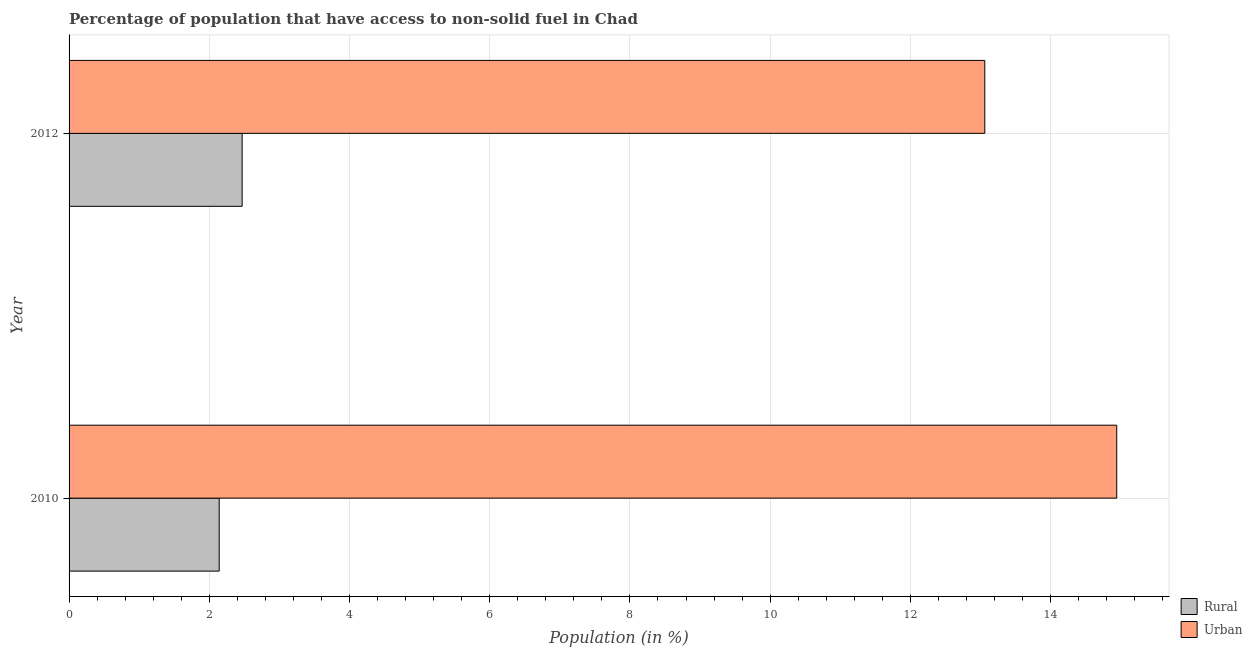How many different coloured bars are there?
Make the answer very short. 2. How many groups of bars are there?
Your answer should be very brief. 2. What is the label of the 1st group of bars from the top?
Your response must be concise. 2012. In how many cases, is the number of bars for a given year not equal to the number of legend labels?
Provide a succinct answer. 0. What is the rural population in 2012?
Provide a succinct answer. 2.47. Across all years, what is the maximum rural population?
Keep it short and to the point. 2.47. Across all years, what is the minimum urban population?
Keep it short and to the point. 13.06. In which year was the rural population maximum?
Provide a succinct answer. 2012. In which year was the rural population minimum?
Make the answer very short. 2010. What is the total rural population in the graph?
Your answer should be compact. 4.61. What is the difference between the rural population in 2010 and that in 2012?
Your response must be concise. -0.33. What is the difference between the rural population in 2010 and the urban population in 2012?
Offer a terse response. -10.92. What is the average urban population per year?
Give a very brief answer. 14. In the year 2012, what is the difference between the urban population and rural population?
Your response must be concise. 10.59. What is the ratio of the urban population in 2010 to that in 2012?
Offer a very short reply. 1.14. Is the rural population in 2010 less than that in 2012?
Provide a short and direct response. Yes. Is the difference between the rural population in 2010 and 2012 greater than the difference between the urban population in 2010 and 2012?
Your answer should be very brief. No. In how many years, is the rural population greater than the average rural population taken over all years?
Give a very brief answer. 1. What does the 2nd bar from the top in 2010 represents?
Your answer should be compact. Rural. What does the 1st bar from the bottom in 2012 represents?
Your response must be concise. Rural. How many bars are there?
Provide a short and direct response. 4. Are all the bars in the graph horizontal?
Make the answer very short. Yes. How many years are there in the graph?
Your answer should be very brief. 2. How are the legend labels stacked?
Offer a terse response. Vertical. What is the title of the graph?
Provide a succinct answer. Percentage of population that have access to non-solid fuel in Chad. Does "Largest city" appear as one of the legend labels in the graph?
Make the answer very short. No. What is the label or title of the X-axis?
Give a very brief answer. Population (in %). What is the label or title of the Y-axis?
Your response must be concise. Year. What is the Population (in %) of Rural in 2010?
Your response must be concise. 2.14. What is the Population (in %) of Urban in 2010?
Offer a very short reply. 14.94. What is the Population (in %) in Rural in 2012?
Give a very brief answer. 2.47. What is the Population (in %) in Urban in 2012?
Offer a terse response. 13.06. Across all years, what is the maximum Population (in %) of Rural?
Your answer should be compact. 2.47. Across all years, what is the maximum Population (in %) of Urban?
Give a very brief answer. 14.94. Across all years, what is the minimum Population (in %) of Rural?
Your answer should be compact. 2.14. Across all years, what is the minimum Population (in %) of Urban?
Provide a short and direct response. 13.06. What is the total Population (in %) in Rural in the graph?
Provide a short and direct response. 4.61. What is the total Population (in %) of Urban in the graph?
Your response must be concise. 28.01. What is the difference between the Population (in %) of Rural in 2010 and that in 2012?
Your response must be concise. -0.33. What is the difference between the Population (in %) in Urban in 2010 and that in 2012?
Provide a succinct answer. 1.88. What is the difference between the Population (in %) in Rural in 2010 and the Population (in %) in Urban in 2012?
Offer a very short reply. -10.92. What is the average Population (in %) in Rural per year?
Provide a short and direct response. 2.31. What is the average Population (in %) of Urban per year?
Offer a very short reply. 14. In the year 2010, what is the difference between the Population (in %) in Rural and Population (in %) in Urban?
Provide a short and direct response. -12.8. In the year 2012, what is the difference between the Population (in %) of Rural and Population (in %) of Urban?
Keep it short and to the point. -10.59. What is the ratio of the Population (in %) in Rural in 2010 to that in 2012?
Your answer should be compact. 0.87. What is the ratio of the Population (in %) of Urban in 2010 to that in 2012?
Your answer should be very brief. 1.14. What is the difference between the highest and the second highest Population (in %) in Rural?
Your response must be concise. 0.33. What is the difference between the highest and the second highest Population (in %) of Urban?
Your answer should be compact. 1.88. What is the difference between the highest and the lowest Population (in %) of Rural?
Your response must be concise. 0.33. What is the difference between the highest and the lowest Population (in %) of Urban?
Your answer should be very brief. 1.88. 